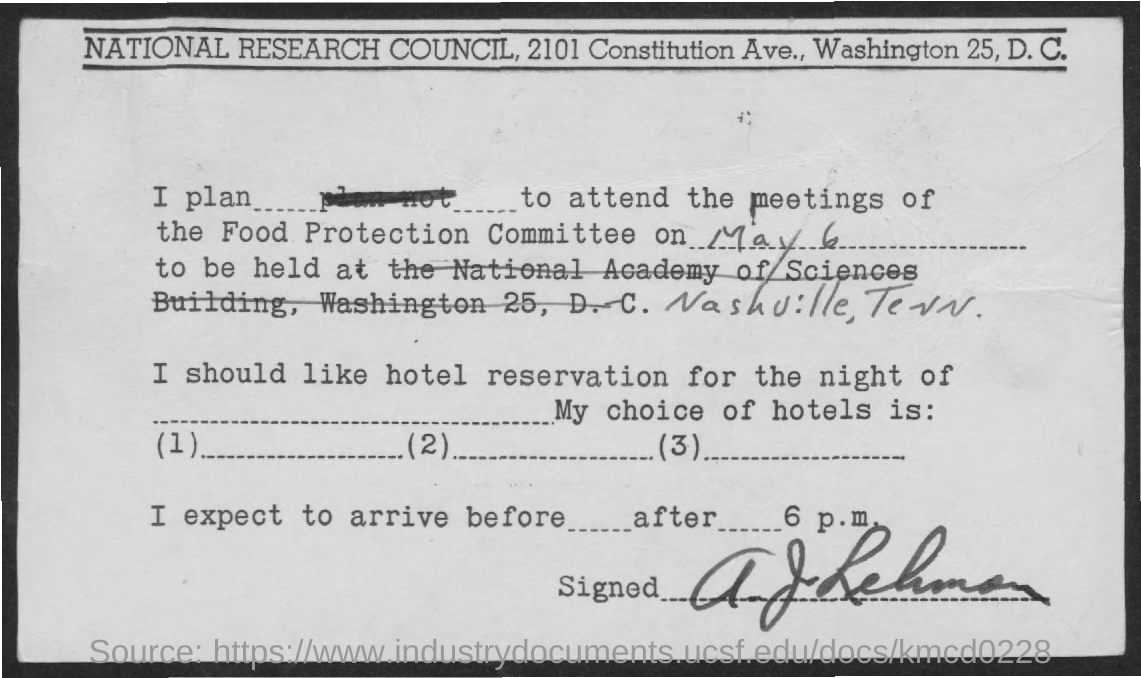Point out several critical features in this image. The event will take place in Nashville, Tennessee. The Food Protection Committee will hold its meeting on May 6. 